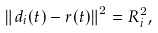Convert formula to latex. <formula><loc_0><loc_0><loc_500><loc_500>\left \| d _ { i } ( t ) - r ( t ) \right \| ^ { 2 } = R ^ { 2 } _ { i } ,</formula> 